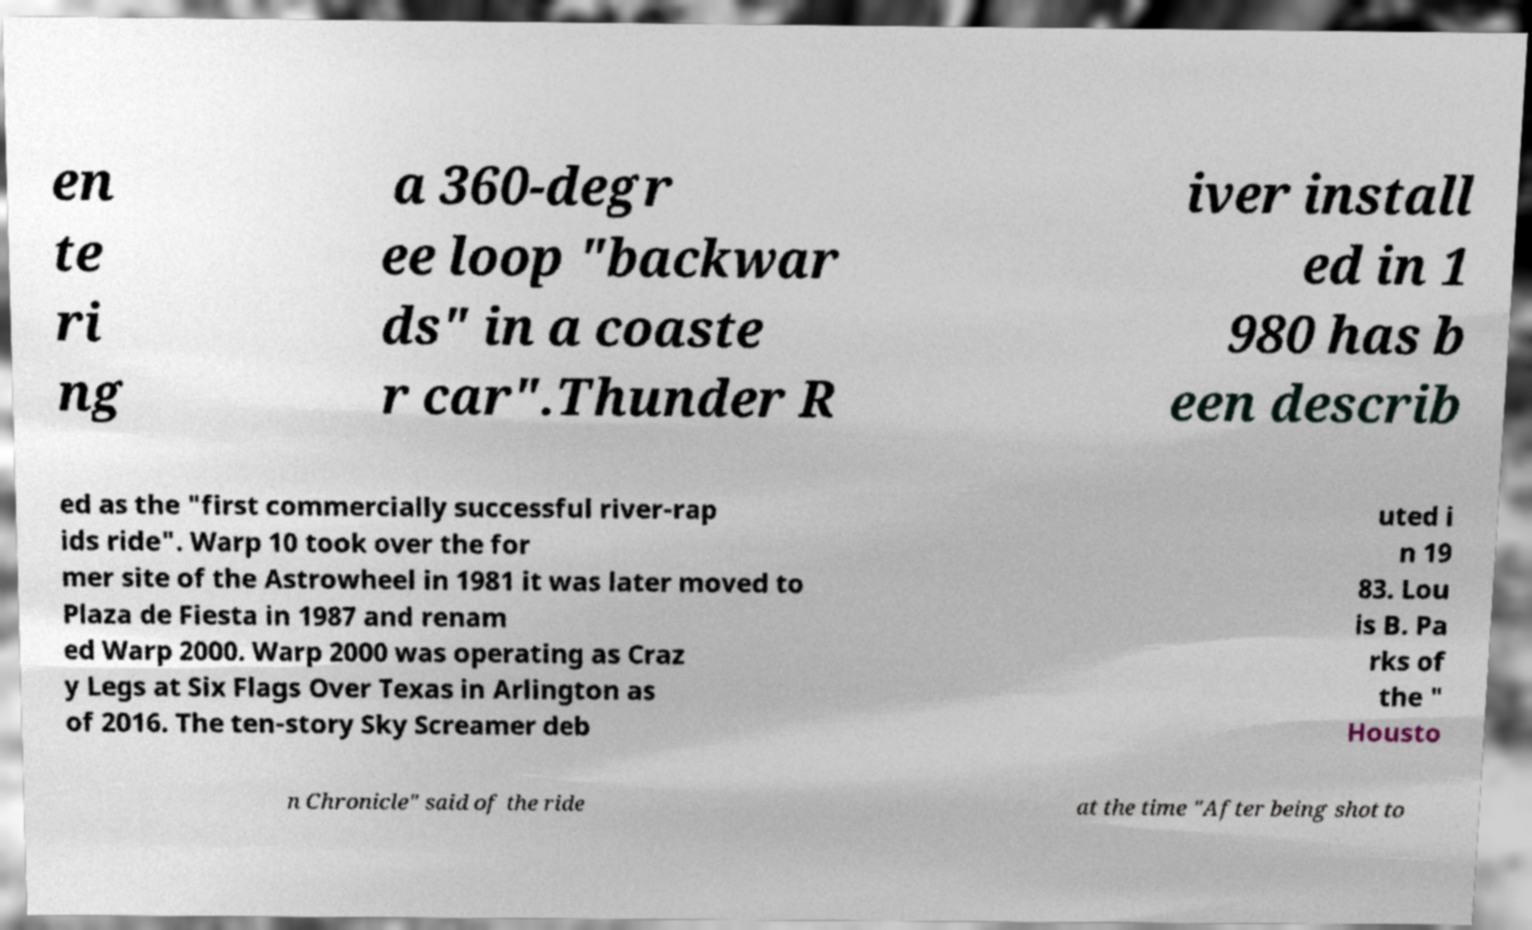Can you accurately transcribe the text from the provided image for me? en te ri ng a 360-degr ee loop "backwar ds" in a coaste r car".Thunder R iver install ed in 1 980 has b een describ ed as the "first commercially successful river-rap ids ride". Warp 10 took over the for mer site of the Astrowheel in 1981 it was later moved to Plaza de Fiesta in 1987 and renam ed Warp 2000. Warp 2000 was operating as Craz y Legs at Six Flags Over Texas in Arlington as of 2016. The ten-story Sky Screamer deb uted i n 19 83. Lou is B. Pa rks of the " Housto n Chronicle" said of the ride at the time "After being shot to 